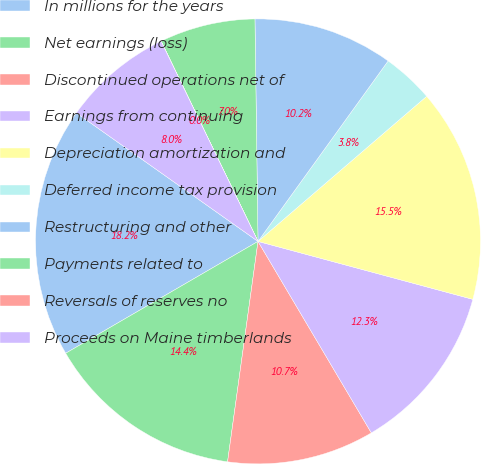<chart> <loc_0><loc_0><loc_500><loc_500><pie_chart><fcel>In millions for the years<fcel>Net earnings (loss)<fcel>Discontinued operations net of<fcel>Earnings from continuing<fcel>Depreciation amortization and<fcel>Deferred income tax provision<fcel>Restructuring and other<fcel>Payments related to<fcel>Reversals of reserves no<fcel>Proceeds on Maine timberlands<nl><fcel>18.18%<fcel>14.43%<fcel>10.69%<fcel>12.3%<fcel>15.5%<fcel>3.75%<fcel>10.16%<fcel>6.95%<fcel>0.01%<fcel>8.02%<nl></chart> 